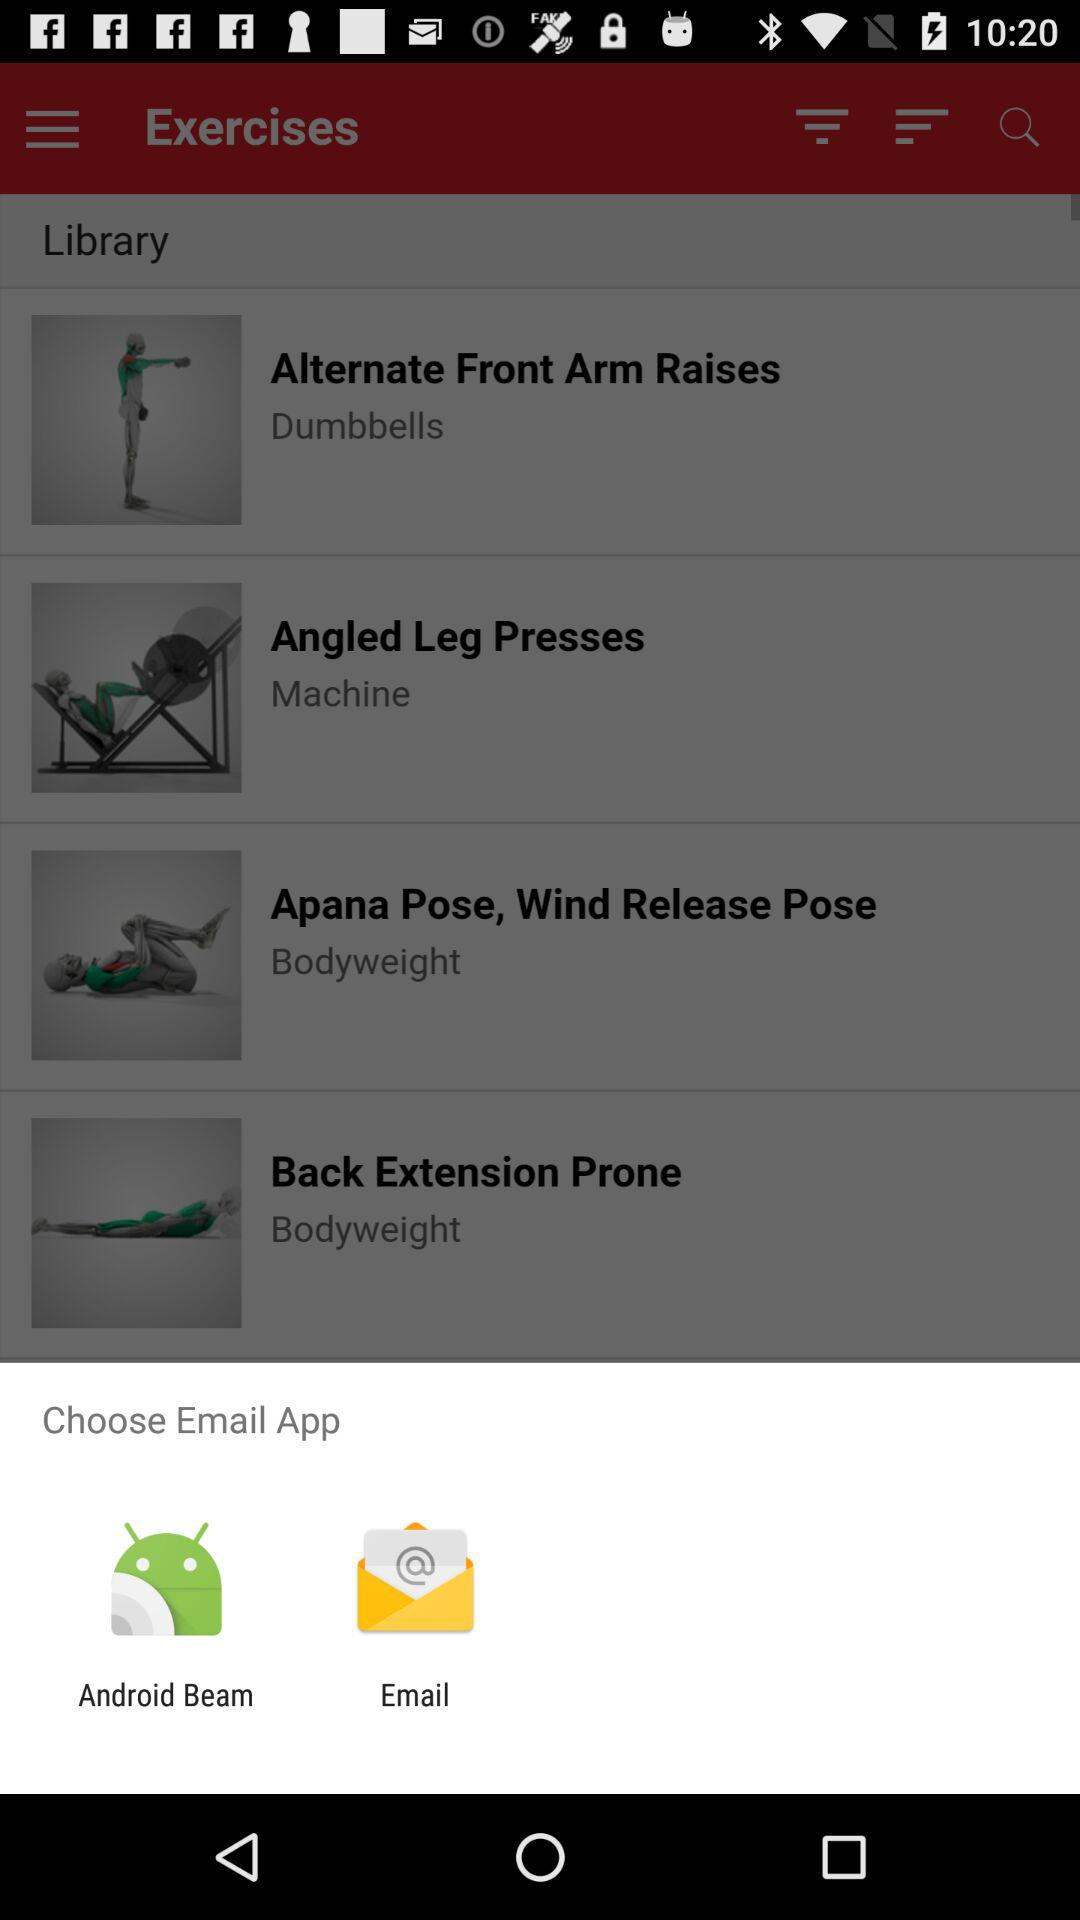Which applications can be used for sending email?
Answer the question using a single word or phrase. The applications are "Android Beam" and "Email." 